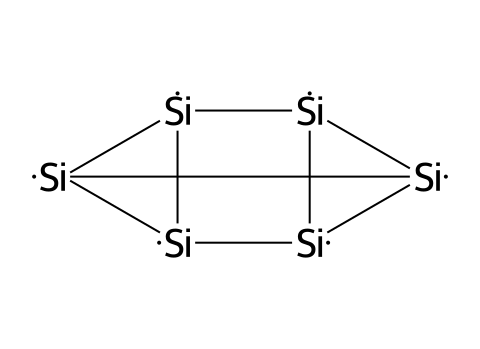How many silicon atoms are in the structure? The SMILES representation indicates multiple silicon atoms. Each [Si] represents a silicon atom, and by counting the total occurrences of [Si] in the structure, we identify the number of silicon atoms.
Answer: six What type of lattice structure does silicon typically form in this crystalline structure? Silicon typically forms a diamond cubic lattice structure in its crystalline form. This can be inferred from the arrangement of silicon atoms in the provided SMILES, which reflects this geometric organization.
Answer: diamond cubic What is the total number of bonds formed by the silicon atoms in this structure? The structure's bonding can be determined by observing the connections outlined in the SMILES representation. Each silicon atom forms four covalent bonds, and considering the regular structure, we can derive the number of bonds. For six silicon atoms, typically 12 significant covalent bonds are present (considering shared bonds).
Answer: twelve What kind of semiconductor is silicon classified as in terms of band gap? Silicon is classified as an indirect band gap semiconductor. This characterization comes from its electronic properties, which can be derived when looking at the arrangement and bonding of silicon atoms in semiconductor applications.
Answer: indirect What is a common application of silicon due to its crystalline structure? Due to its crystalline structure and electronic properties, silicon is commonly used in the manufacture of computer chips and semiconductors. This is a well-known application of silicon which directly relates to its structural characteristics.
Answer: computer chips What characteristic of crystalline silicon allows it to effectively conduct electricity? The well-organized crystalline structure of silicon allows for the creation of energy bands, enabling the movement of charge carriers when doped appropriately. This property is essential in its use as a semiconductor.
Answer: charge carriers 